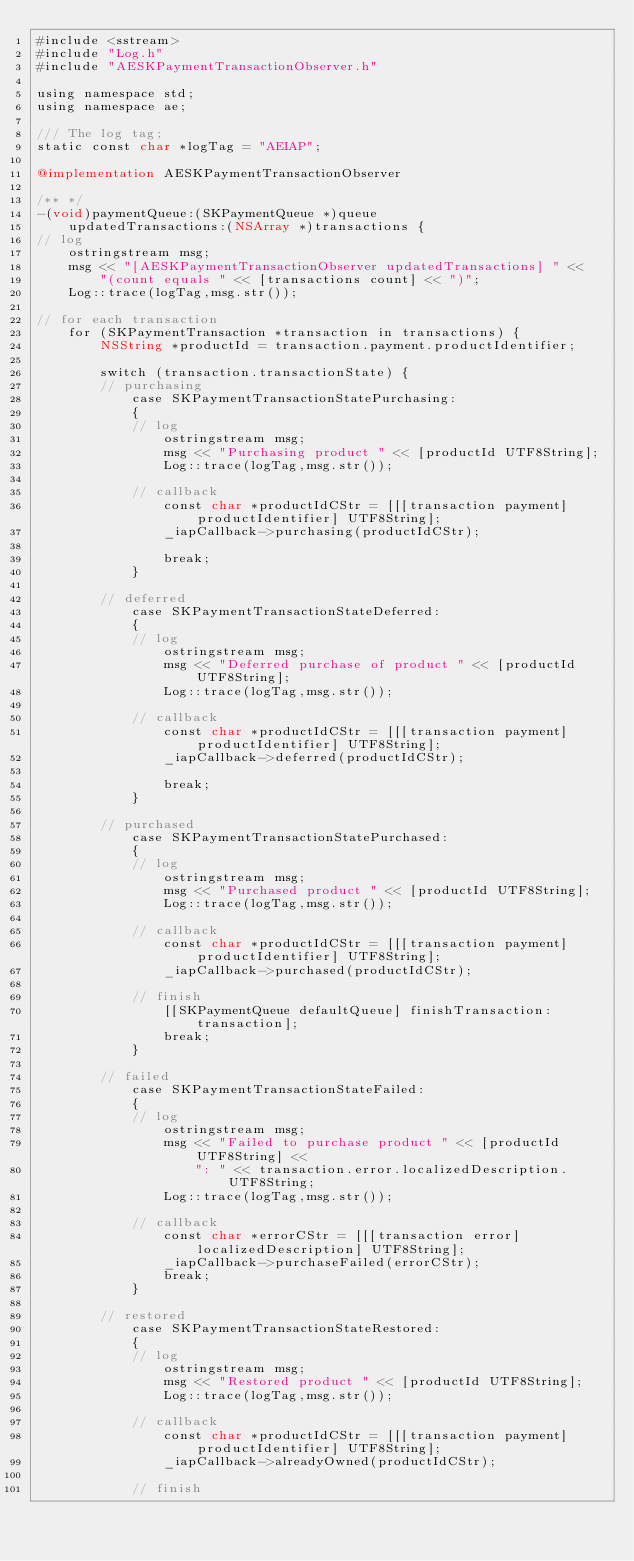Convert code to text. <code><loc_0><loc_0><loc_500><loc_500><_ObjectiveC_>#include <sstream>
#include "Log.h"
#include "AESKPaymentTransactionObserver.h"

using namespace std;
using namespace ae;

/// The log tag;
static const char *logTag = "AEIAP";

@implementation AESKPaymentTransactionObserver

/** */
-(void)paymentQueue:(SKPaymentQueue *)queue
    updatedTransactions:(NSArray *)transactions {
// log
    ostringstream msg;
    msg << "[AESKPaymentTransactionObserver updatedTransactions] " <<
        "(count equals " << [transactions count] << ")";
    Log::trace(logTag,msg.str());
    
// for each transaction
    for (SKPaymentTransaction *transaction in transactions) {
        NSString *productId = transaction.payment.productIdentifier;
        
        switch (transaction.transactionState) {
        // purchasing
            case SKPaymentTransactionStatePurchasing:
            {
            // log
                ostringstream msg;
                msg << "Purchasing product " << [productId UTF8String];
                Log::trace(logTag,msg.str());
                
            // callback
                const char *productIdCStr = [[[transaction payment] productIdentifier] UTF8String];
                _iapCallback->purchasing(productIdCStr);
                
                break;
            }

        // deferred
            case SKPaymentTransactionStateDeferred:
            {
            // log
                ostringstream msg;
                msg << "Deferred purchase of product " << [productId UTF8String];
                Log::trace(logTag,msg.str());
                
            // callback
                const char *productIdCStr = [[[transaction payment] productIdentifier] UTF8String];
                _iapCallback->deferred(productIdCStr);
                
                break;
            }

        // purchased
            case SKPaymentTransactionStatePurchased:
            {
            // log
                ostringstream msg;
                msg << "Purchased product " << [productId UTF8String];
                Log::trace(logTag,msg.str());
                
            // callback
                const char *productIdCStr = [[[transaction payment] productIdentifier] UTF8String];
                _iapCallback->purchased(productIdCStr);
                
            // finish
                [[SKPaymentQueue defaultQueue] finishTransaction:transaction];
                break;
            }

        // failed
            case SKPaymentTransactionStateFailed:
            {
            // log
                ostringstream msg;
                msg << "Failed to purchase product " << [productId UTF8String] <<
                    ": " << transaction.error.localizedDescription.UTF8String;
                Log::trace(logTag,msg.str());
                
            // callback
                const char *errorCStr = [[[transaction error] localizedDescription] UTF8String];
                _iapCallback->purchaseFailed(errorCStr);
                break;
            }
            
        // restored
            case SKPaymentTransactionStateRestored:
            {
            // log
                ostringstream msg;
                msg << "Restored product " << [productId UTF8String];
                Log::trace(logTag,msg.str());
                
            // callback
                const char *productIdCStr = [[[transaction payment] productIdentifier] UTF8String];
                _iapCallback->alreadyOwned(productIdCStr);
                
            // finish</code> 